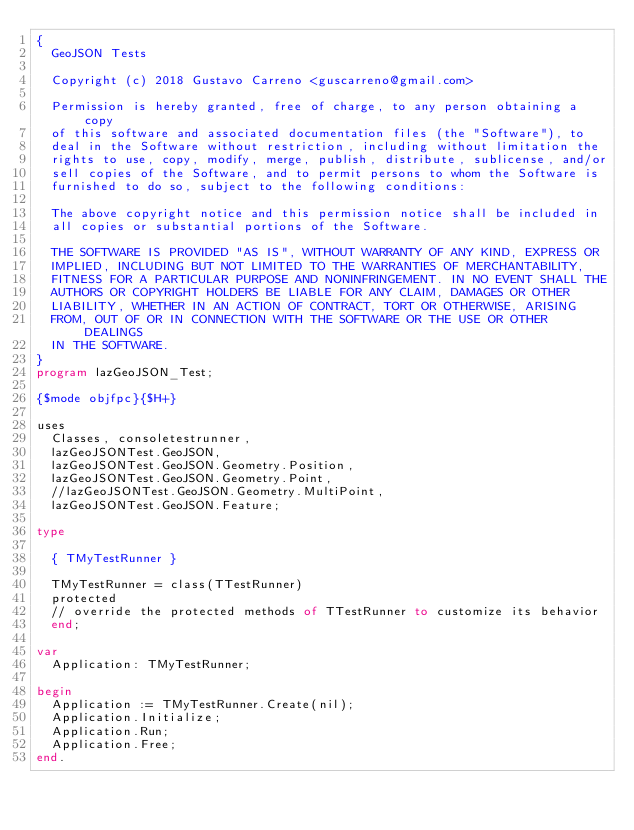Convert code to text. <code><loc_0><loc_0><loc_500><loc_500><_Pascal_>{
  GeoJSON Tests

  Copyright (c) 2018 Gustavo Carreno <guscarreno@gmail.com>

  Permission is hereby granted, free of charge, to any person obtaining a copy
  of this software and associated documentation files (the "Software"), to
  deal in the Software without restriction, including without limitation the
  rights to use, copy, modify, merge, publish, distribute, sublicense, and/or
  sell copies of the Software, and to permit persons to whom the Software is
  furnished to do so, subject to the following conditions:

  The above copyright notice and this permission notice shall be included in
  all copies or substantial portions of the Software.

  THE SOFTWARE IS PROVIDED "AS IS", WITHOUT WARRANTY OF ANY KIND, EXPRESS OR
  IMPLIED, INCLUDING BUT NOT LIMITED TO THE WARRANTIES OF MERCHANTABILITY,
  FITNESS FOR A PARTICULAR PURPOSE AND NONINFRINGEMENT. IN NO EVENT SHALL THE
  AUTHORS OR COPYRIGHT HOLDERS BE LIABLE FOR ANY CLAIM, DAMAGES OR OTHER
  LIABILITY, WHETHER IN AN ACTION OF CONTRACT, TORT OR OTHERWISE, ARISING
  FROM, OUT OF OR IN CONNECTION WITH THE SOFTWARE OR THE USE OR OTHER DEALINGS
  IN THE SOFTWARE.
}
program lazGeoJSON_Test;

{$mode objfpc}{$H+}

uses
  Classes, consoletestrunner,
  lazGeoJSONTest.GeoJSON,
  lazGeoJSONTest.GeoJSON.Geometry.Position,
  lazGeoJSONTest.GeoJSON.Geometry.Point,
  //lazGeoJSONTest.GeoJSON.Geometry.MultiPoint,
  lazGeoJSONTest.GeoJSON.Feature;

type

  { TMyTestRunner }

  TMyTestRunner = class(TTestRunner)
  protected
  // override the protected methods of TTestRunner to customize its behavior
  end;

var
  Application: TMyTestRunner;

begin
  Application := TMyTestRunner.Create(nil);
  Application.Initialize;
  Application.Run;
  Application.Free;
end.
</code> 